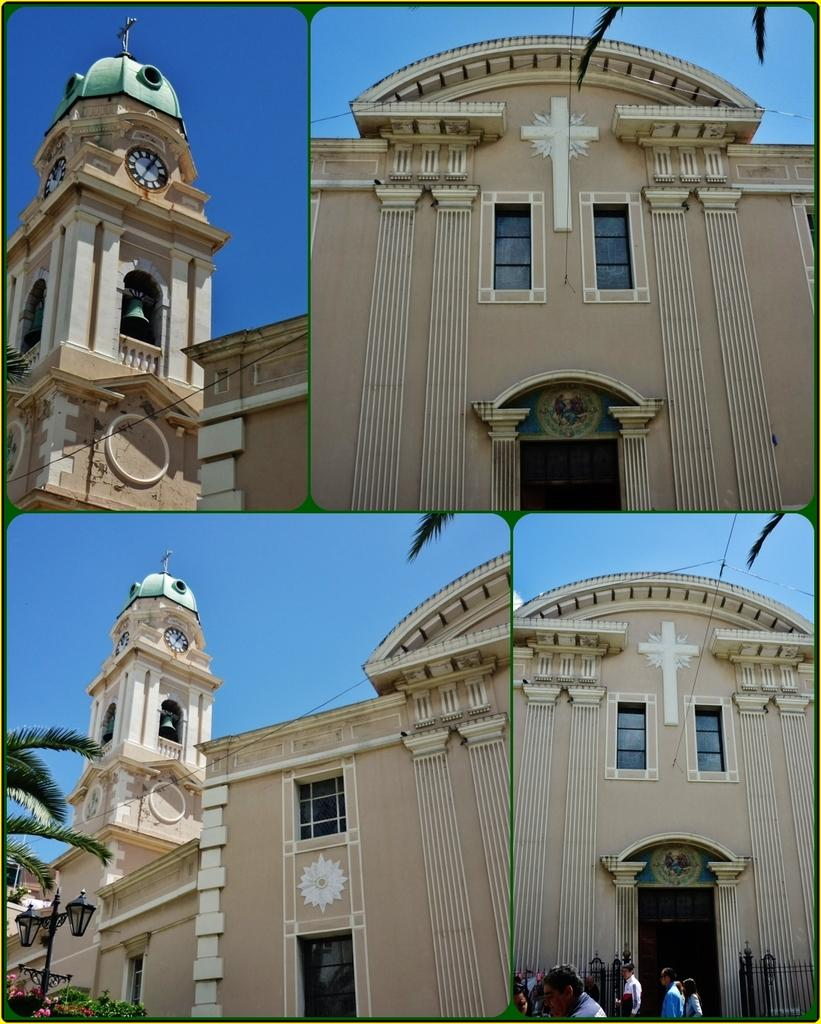What types of structures are depicted in the collage? The collage contains pictures of a building. What natural elements are present in the collage? The collage contains pictures of a tree and plants. What artificial elements are present in the collage? The collage contains pictures of lights. Who or what is represented in the collage? The collage contains pictures of people. What type of tin is visible in the collage? There is no tin present in the collage. What shape is the square in the collage? There is no square present in the collage. 